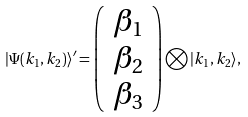<formula> <loc_0><loc_0><loc_500><loc_500>| \Psi ( k _ { 1 } , k _ { 2 } ) \rangle ^ { \prime } = \left ( \begin{array} { c } \beta _ { 1 } \\ \beta _ { 2 } \\ \beta _ { 3 } \end{array} \right ) \bigotimes | k _ { 1 } , k _ { 2 } \rangle ,</formula> 